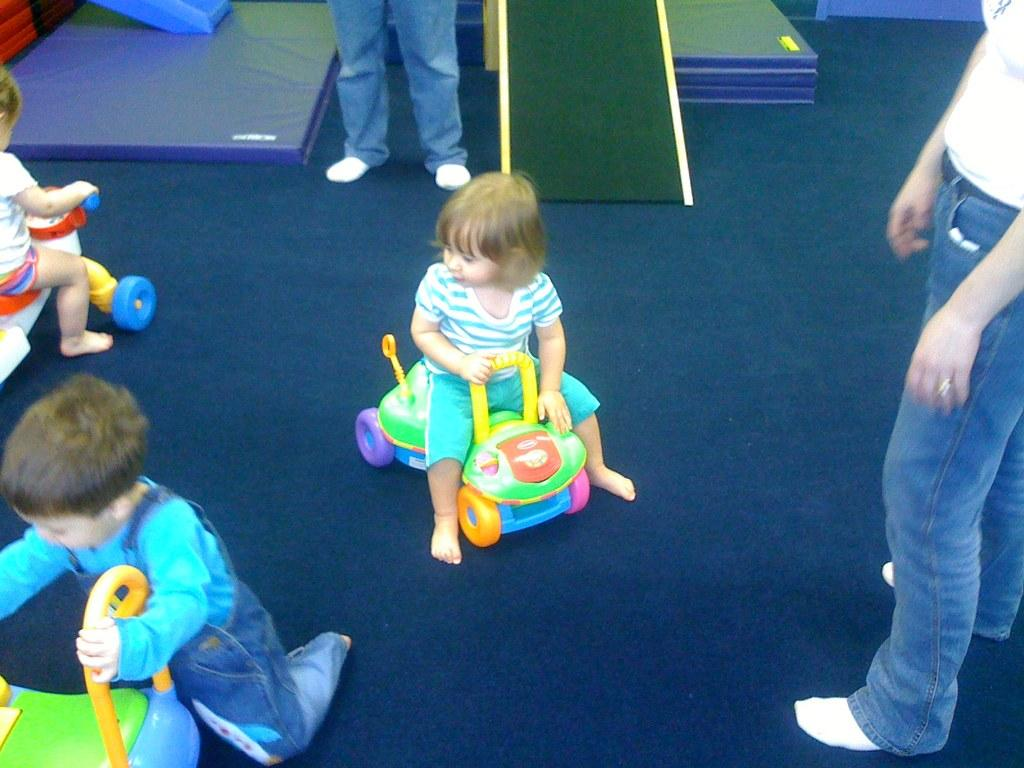What are the kids doing in the image? There are two kids sitting on toys in the image. What is the boy holding in the image? There is a boy holding a toy in the image. How many people are standing in the image? There are two people standing in the image. What can be seen on the floor in the background of the image? There are objects on the floor in the background of the image. What type of amusement can be seen in the image involving cows? There is no amusement involving cows present in the image. How many dolls are visible in the image? There are no dolls visible in the image. 